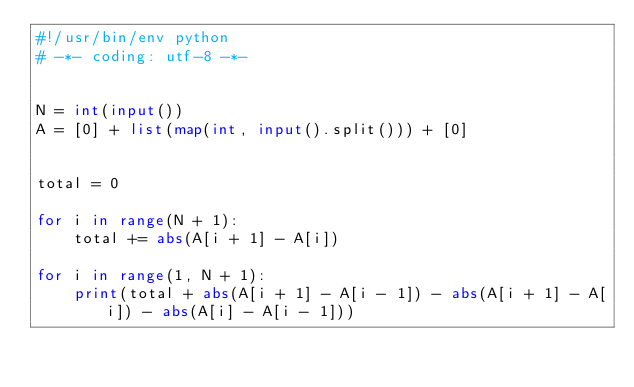<code> <loc_0><loc_0><loc_500><loc_500><_Python_>#!/usr/bin/env python
# -*- coding: utf-8 -*-


N = int(input())
A = [0] + list(map(int, input().split())) + [0]


total = 0

for i in range(N + 1):
    total += abs(A[i + 1] - A[i])

for i in range(1, N + 1):
    print(total + abs(A[i + 1] - A[i - 1]) - abs(A[i + 1] - A[i]) - abs(A[i] - A[i - 1]))
</code> 